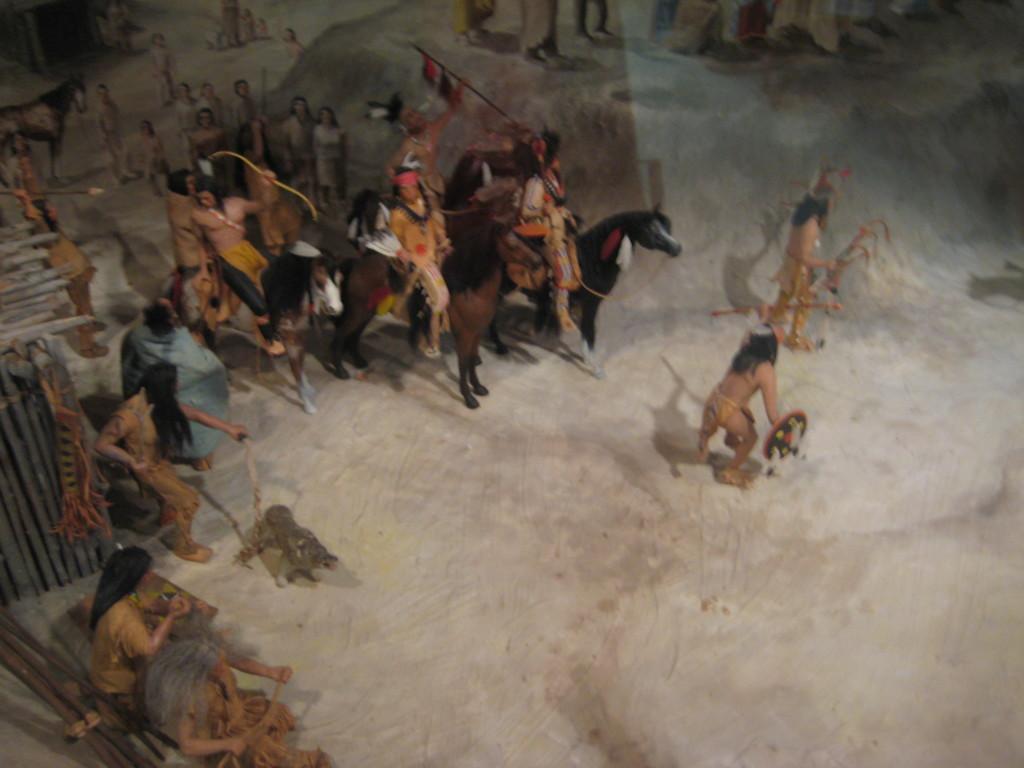Can you describe this image briefly? In this picture I can see this is a depiction image and I see number of people and I see few of them are sitting on horses and I see few of them are holding things in their hands. 